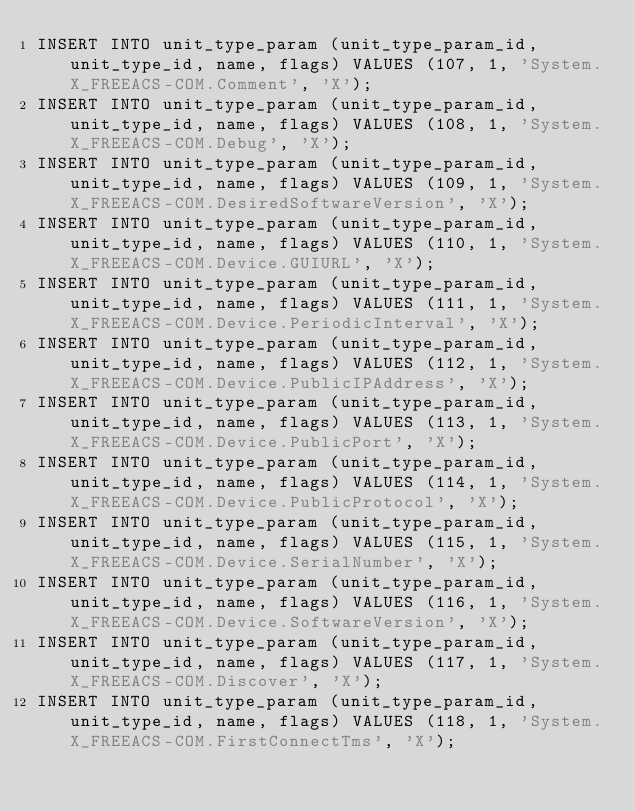Convert code to text. <code><loc_0><loc_0><loc_500><loc_500><_SQL_>INSERT INTO unit_type_param (unit_type_param_id, unit_type_id, name, flags) VALUES (107, 1, 'System.X_FREEACS-COM.Comment', 'X');
INSERT INTO unit_type_param (unit_type_param_id, unit_type_id, name, flags) VALUES (108, 1, 'System.X_FREEACS-COM.Debug', 'X');
INSERT INTO unit_type_param (unit_type_param_id, unit_type_id, name, flags) VALUES (109, 1, 'System.X_FREEACS-COM.DesiredSoftwareVersion', 'X');
INSERT INTO unit_type_param (unit_type_param_id, unit_type_id, name, flags) VALUES (110, 1, 'System.X_FREEACS-COM.Device.GUIURL', 'X');
INSERT INTO unit_type_param (unit_type_param_id, unit_type_id, name, flags) VALUES (111, 1, 'System.X_FREEACS-COM.Device.PeriodicInterval', 'X');
INSERT INTO unit_type_param (unit_type_param_id, unit_type_id, name, flags) VALUES (112, 1, 'System.X_FREEACS-COM.Device.PublicIPAddress', 'X');
INSERT INTO unit_type_param (unit_type_param_id, unit_type_id, name, flags) VALUES (113, 1, 'System.X_FREEACS-COM.Device.PublicPort', 'X');
INSERT INTO unit_type_param (unit_type_param_id, unit_type_id, name, flags) VALUES (114, 1, 'System.X_FREEACS-COM.Device.PublicProtocol', 'X');
INSERT INTO unit_type_param (unit_type_param_id, unit_type_id, name, flags) VALUES (115, 1, 'System.X_FREEACS-COM.Device.SerialNumber', 'X');
INSERT INTO unit_type_param (unit_type_param_id, unit_type_id, name, flags) VALUES (116, 1, 'System.X_FREEACS-COM.Device.SoftwareVersion', 'X');
INSERT INTO unit_type_param (unit_type_param_id, unit_type_id, name, flags) VALUES (117, 1, 'System.X_FREEACS-COM.Discover', 'X');
INSERT INTO unit_type_param (unit_type_param_id, unit_type_id, name, flags) VALUES (118, 1, 'System.X_FREEACS-COM.FirstConnectTms', 'X');</code> 